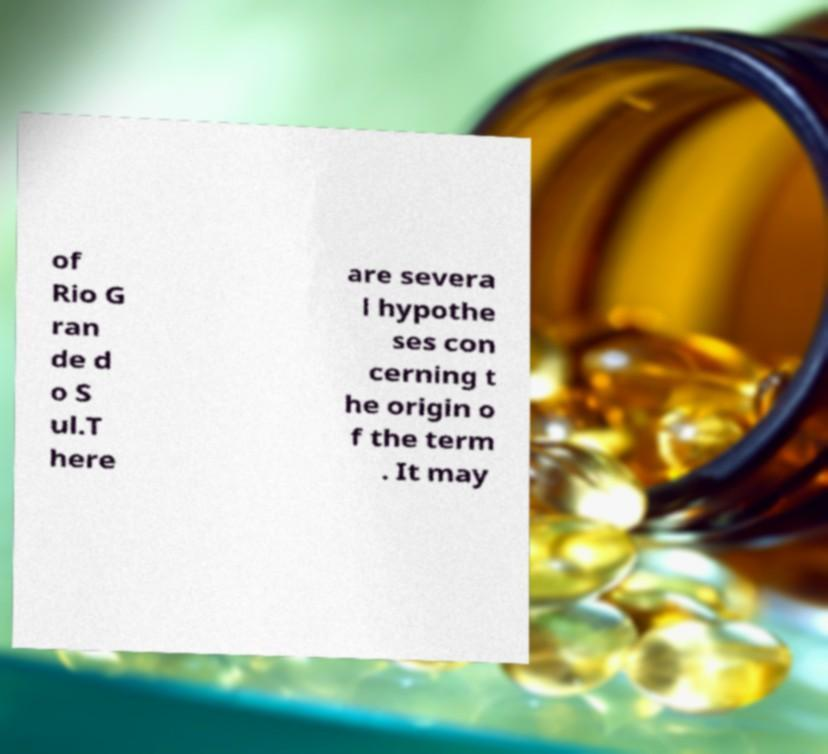Can you accurately transcribe the text from the provided image for me? of Rio G ran de d o S ul.T here are severa l hypothe ses con cerning t he origin o f the term . It may 